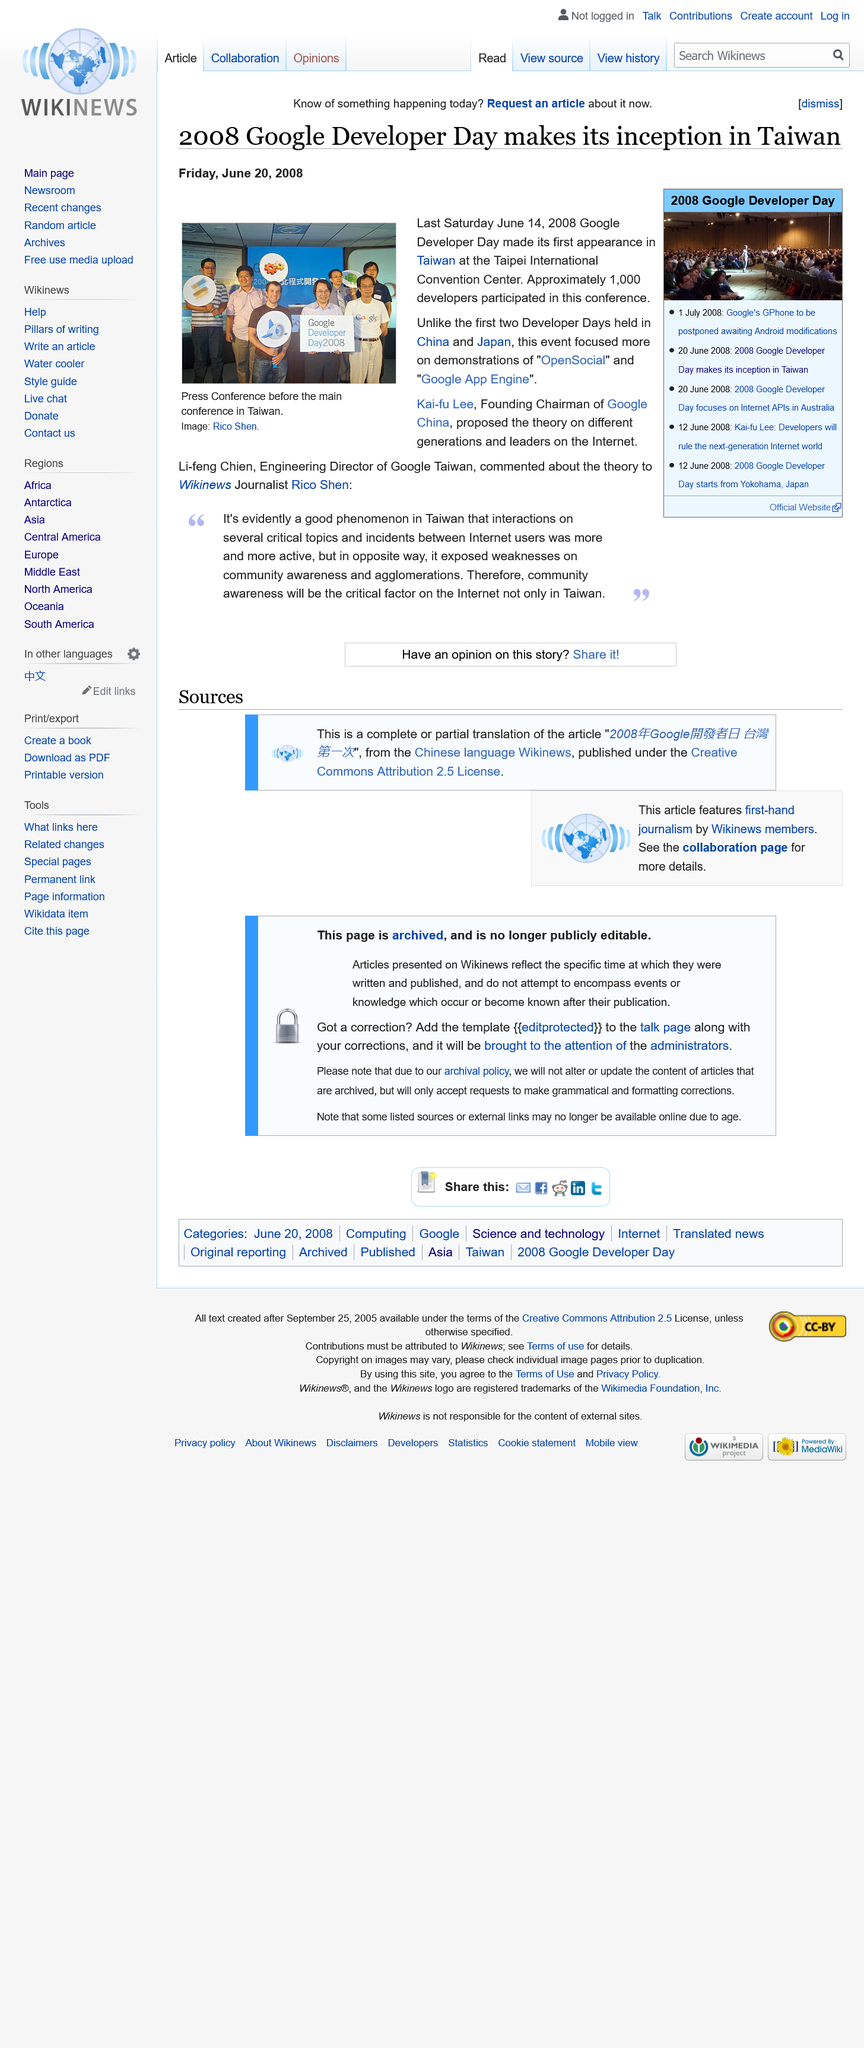Give some essential details in this illustration. The founding chairman of Google China is Kai-fu Lee. Google Developer Day 2008 was held in Taiwan on Friday, June 20, 2008. The article's photograph was taken by Rico Shen. 